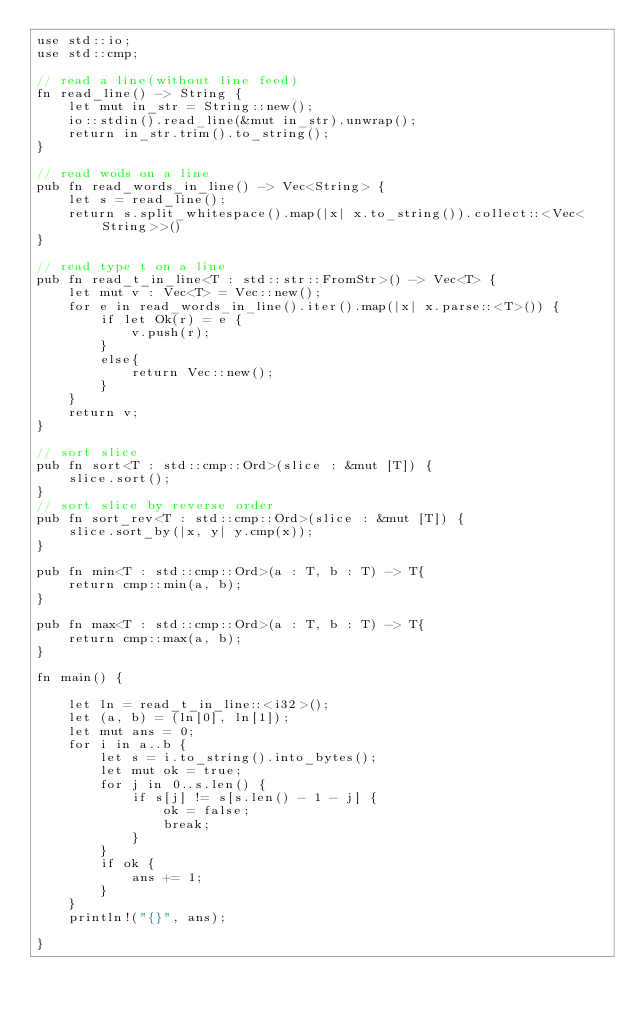Convert code to text. <code><loc_0><loc_0><loc_500><loc_500><_Rust_>use std::io;
use std::cmp;

// read a line(without line feed)
fn read_line() -> String {
    let mut in_str = String::new();
    io::stdin().read_line(&mut in_str).unwrap();
    return in_str.trim().to_string();
}

// read wods on a line
pub fn read_words_in_line() -> Vec<String> {
    let s = read_line();
    return s.split_whitespace().map(|x| x.to_string()).collect::<Vec<String>>()
}

// read type t on a line
pub fn read_t_in_line<T : std::str::FromStr>() -> Vec<T> {
    let mut v : Vec<T> = Vec::new();
    for e in read_words_in_line().iter().map(|x| x.parse::<T>()) {
        if let Ok(r) = e {
            v.push(r);
        }
        else{
            return Vec::new();
        }
    }
    return v;
}

// sort slice
pub fn sort<T : std::cmp::Ord>(slice : &mut [T]) {
    slice.sort();
}
// sort slice by reverse order
pub fn sort_rev<T : std::cmp::Ord>(slice : &mut [T]) {
    slice.sort_by(|x, y| y.cmp(x));
}

pub fn min<T : std::cmp::Ord>(a : T, b : T) -> T{
    return cmp::min(a, b);
}

pub fn max<T : std::cmp::Ord>(a : T, b : T) -> T{
    return cmp::max(a, b);
}

fn main() {

    let ln = read_t_in_line::<i32>();
    let (a, b) = (ln[0], ln[1]);
    let mut ans = 0;
    for i in a..b {
        let s = i.to_string().into_bytes();
        let mut ok = true;
        for j in 0..s.len() {
            if s[j] != s[s.len() - 1 - j] {
                ok = false;
                break;
            }
        }
        if ok {
            ans += 1;
        }
    }
    println!("{}", ans);

}
</code> 